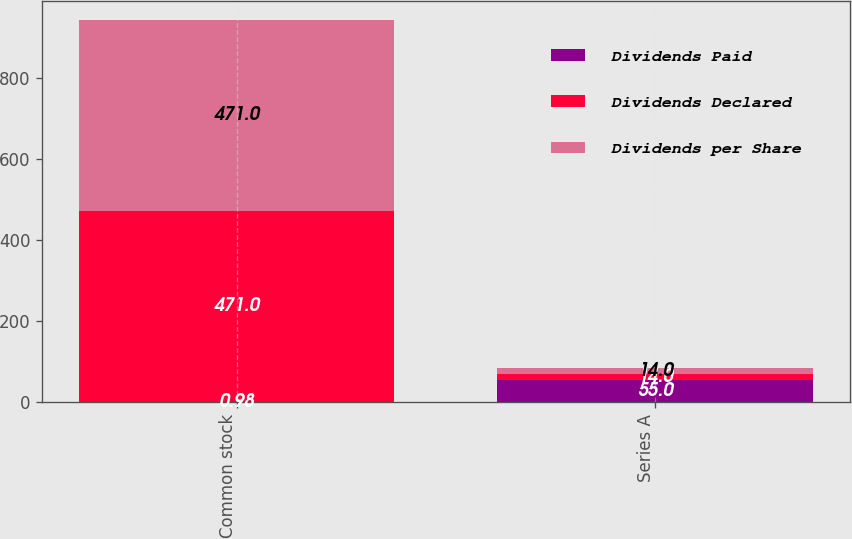Convert chart. <chart><loc_0><loc_0><loc_500><loc_500><stacked_bar_chart><ecel><fcel>Common stock<fcel>Series A<nl><fcel>Dividends Paid<fcel>0.98<fcel>55<nl><fcel>Dividends Declared<fcel>471<fcel>14<nl><fcel>Dividends per Share<fcel>471<fcel>14<nl></chart> 